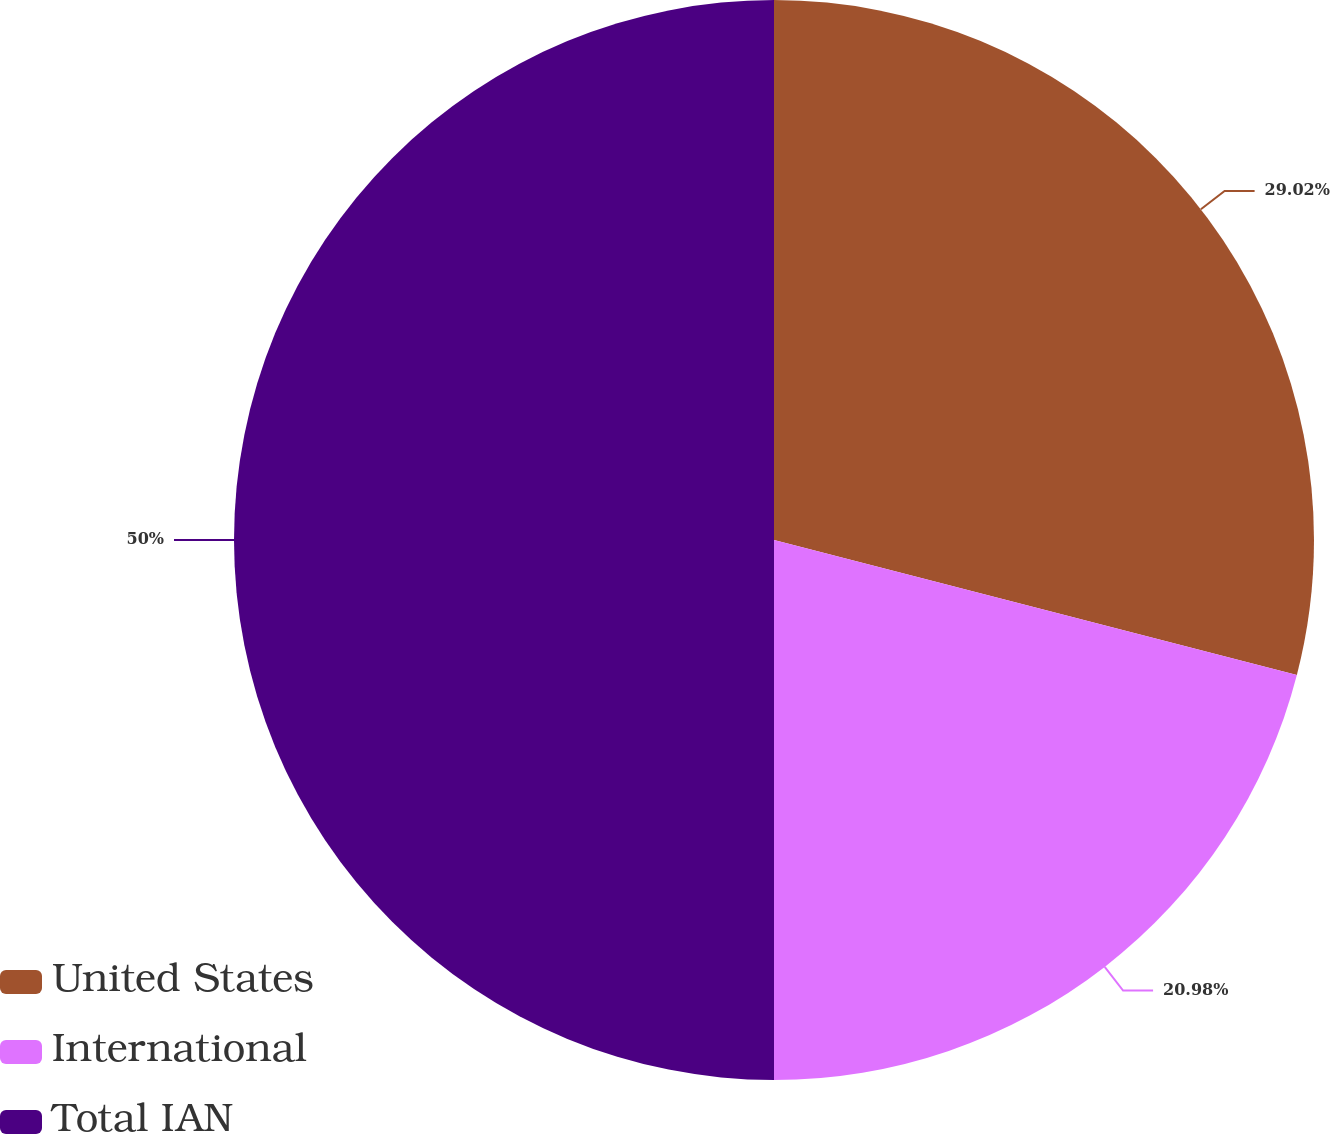<chart> <loc_0><loc_0><loc_500><loc_500><pie_chart><fcel>United States<fcel>International<fcel>Total IAN<nl><fcel>29.02%<fcel>20.98%<fcel>50.0%<nl></chart> 